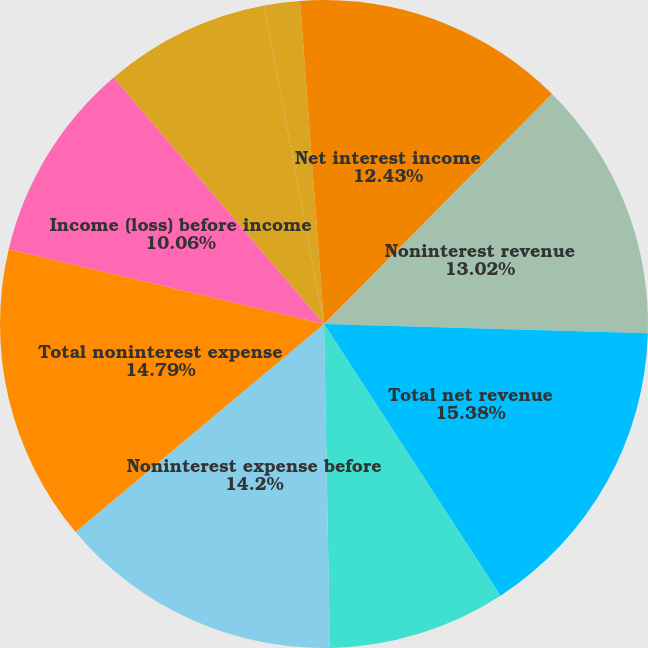Convert chart. <chart><loc_0><loc_0><loc_500><loc_500><pie_chart><fcel>Net interest income<fcel>Noninterest revenue<fcel>Total net revenue<fcel>Provision for credit losses<fcel>Noninterest expense before<fcel>Total noninterest expense<fcel>Income (loss) before income<fcel>Income tax expense (benefit)<fcel>Net income (loss) per share<fcel>Diluted<nl><fcel>12.43%<fcel>13.02%<fcel>15.38%<fcel>8.88%<fcel>14.2%<fcel>14.79%<fcel>10.06%<fcel>8.28%<fcel>1.78%<fcel>1.18%<nl></chart> 